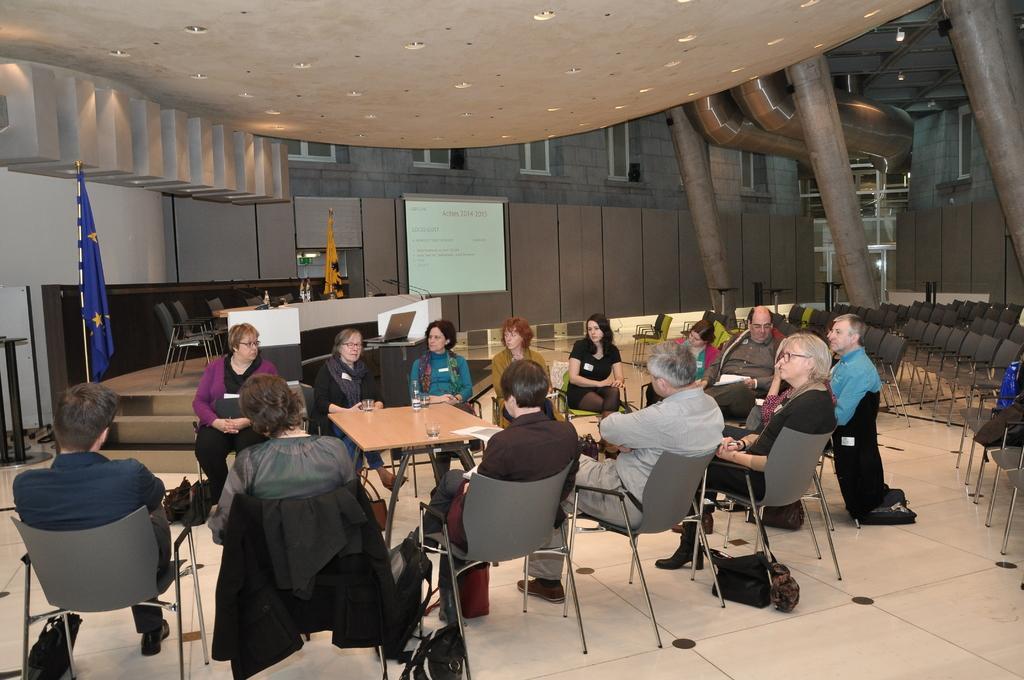Can you describe this image briefly? This picture is clicked in a building. There are group of people sitting around a table. On the table there are glasses. Towards the left there is a flag which is in blue , there is another flag which is in yellow in color. Towards the right there are empty chairs, there are three pillars towards the right. In the center there is a board with some text written on it. In the left bottom there is a bag which is in black in color. There are three people facing backwards and remaining people are facing forward. 